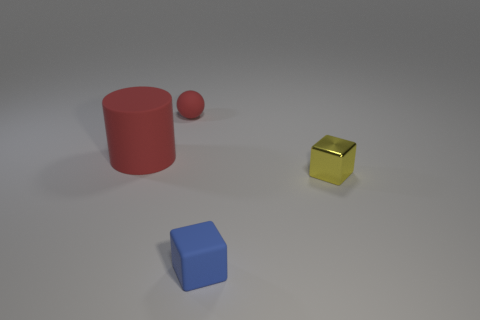Add 2 big objects. How many objects exist? 6 Subtract 2 cubes. How many cubes are left? 0 Subtract 1 yellow cubes. How many objects are left? 3 Subtract all cylinders. How many objects are left? 3 Subtract all purple balls. Subtract all cyan cubes. How many balls are left? 1 Subtract all purple spheres. How many yellow blocks are left? 1 Subtract all small cylinders. Subtract all large rubber cylinders. How many objects are left? 3 Add 1 tiny yellow metallic things. How many tiny yellow metallic things are left? 2 Add 1 big gray matte cylinders. How many big gray matte cylinders exist? 1 